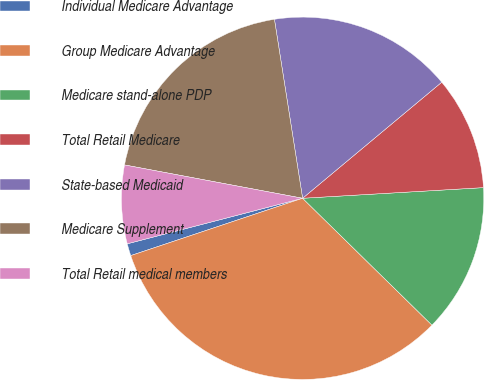Convert chart. <chart><loc_0><loc_0><loc_500><loc_500><pie_chart><fcel>Individual Medicare Advantage<fcel>Group Medicare Advantage<fcel>Medicare stand-alone PDP<fcel>Total Retail Medicare<fcel>State-based Medicaid<fcel>Medicare Supplement<fcel>Total Retail medical members<nl><fcel>1.08%<fcel>32.53%<fcel>13.28%<fcel>10.13%<fcel>16.42%<fcel>19.57%<fcel>6.99%<nl></chart> 